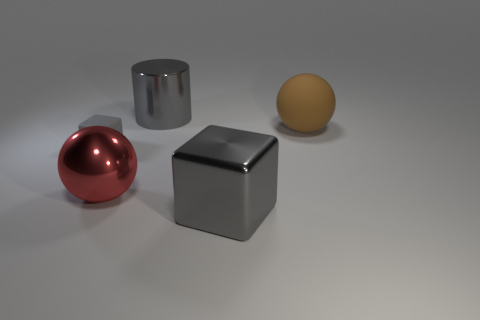There is a gray object that is in front of the big red shiny object; is its shape the same as the tiny gray matte thing to the left of the large red metal object?
Give a very brief answer. Yes. What is the shape of the gray object that is the same size as the gray shiny cube?
Make the answer very short. Cylinder. Is the large sphere to the left of the brown rubber sphere made of the same material as the cube that is to the right of the red sphere?
Provide a short and direct response. Yes. Are there any cubes that are in front of the sphere right of the large red thing?
Your answer should be very brief. Yes. The cube that is made of the same material as the brown sphere is what color?
Your response must be concise. Gray. Are there more metal cylinders than small shiny balls?
Your answer should be compact. Yes. What number of objects are either gray shiny objects in front of the tiny gray thing or tiny brown metal spheres?
Make the answer very short. 1. Are there any metal blocks that have the same size as the brown thing?
Your response must be concise. Yes. Are there fewer metallic blocks than large red metal cubes?
Offer a very short reply. No. How many blocks are either red shiny things or brown matte objects?
Offer a terse response. 0. 